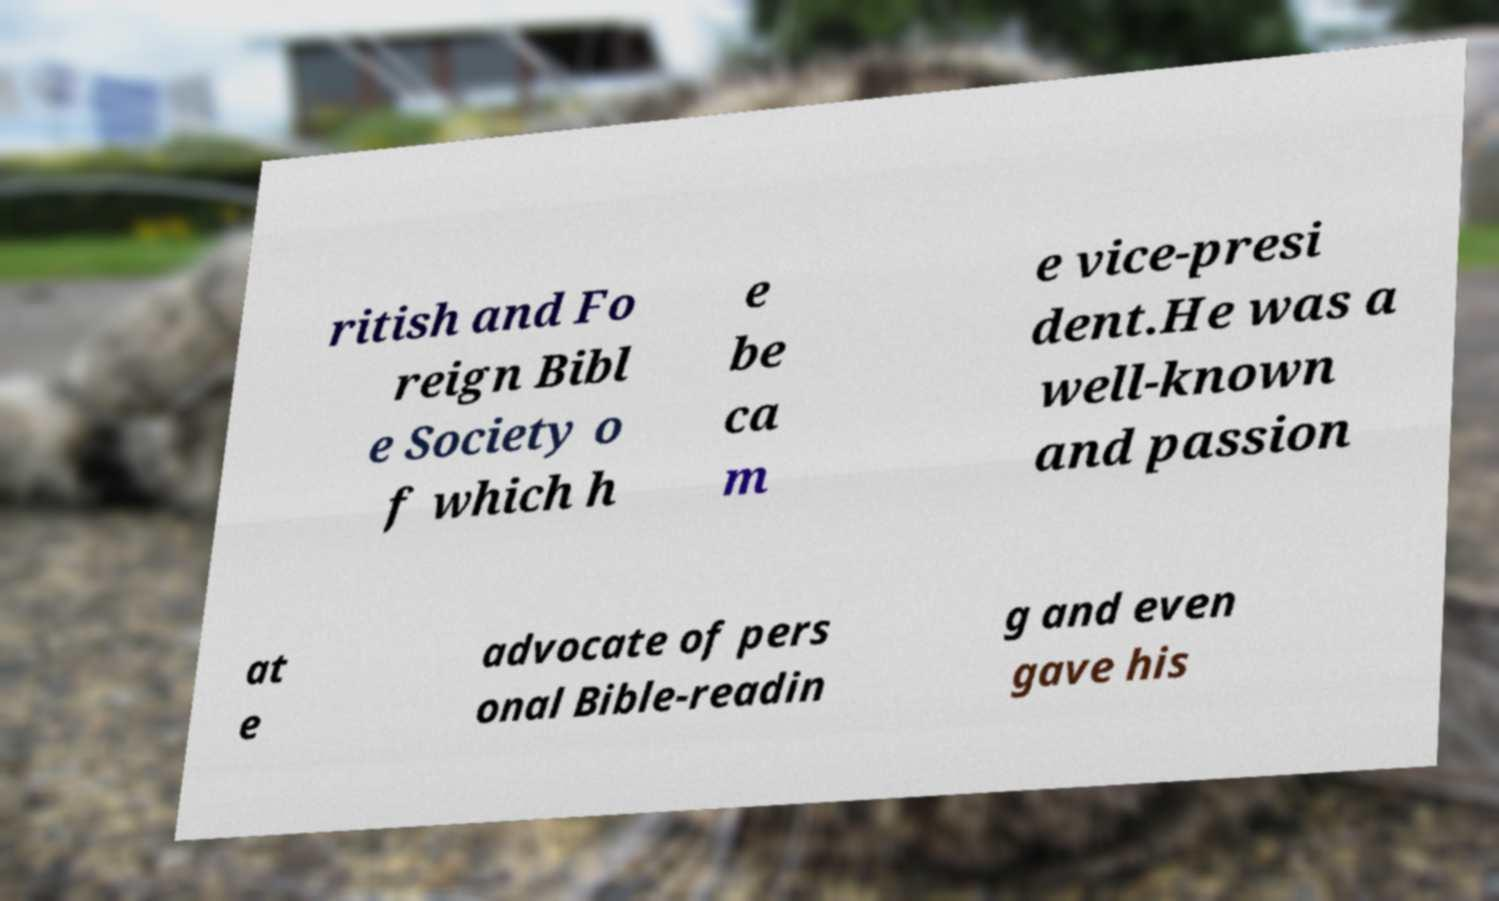Could you extract and type out the text from this image? ritish and Fo reign Bibl e Society o f which h e be ca m e vice-presi dent.He was a well-known and passion at e advocate of pers onal Bible-readin g and even gave his 